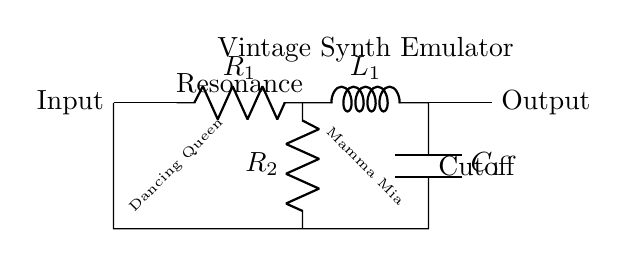What type of components are present in this circuit? The circuit contains a resistor, inductor, and capacitor, which are essential components in a resonant low-pass filter.
Answer: Resistor, Inductor, Capacitor What is the purpose of the second resistor labeled R2? R2 functions as a resonance control, allowing adjustment of the filter's resonance characteristic to shape the sound better.
Answer: Resonance control How many components are there in the filter section of the circuit? The filter section includes three components: one resistor, one inductor, and one capacitor. This forms a resonant low-pass filter configuration.
Answer: Three What does C1 represent in this circuit? C1 is the capacitor in the filter circuit and plays a critical role in determining the cutoff frequency along with the inductor and the resistors.
Answer: Capacitor What effect does increasing R2 have on the circuit? Increasing R2 increases the resonance of the filter, which can lead to a more pronounced peaking effect at the cutoff frequency, enhancing certain frequencies.
Answer: Increases resonance What is the configuration of the filter described here? The configuration is a low-pass filter, which allows frequencies below the cutoff frequency to pass and attenuates frequencies above it.
Answer: Low-pass filter What is indicated by the labels “Dancing Queen” and “Mamma Mia”? These labels are playful elements incorporated into the schematic, referencing iconic ABBA songs that could inspire the circuit’s sound design approach.
Answer: ABBA songs reference 